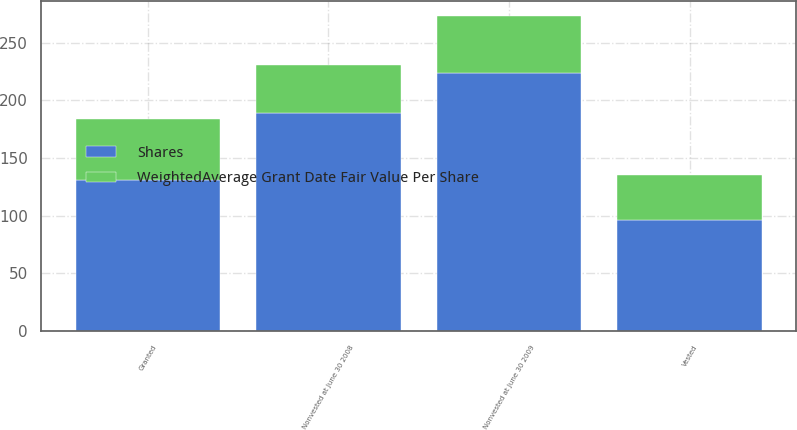Convert chart. <chart><loc_0><loc_0><loc_500><loc_500><stacked_bar_chart><ecel><fcel>Nonvested at June 30 2008<fcel>Granted<fcel>Vested<fcel>Nonvested at June 30 2009<nl><fcel>Shares<fcel>189.3<fcel>131<fcel>96.1<fcel>224.2<nl><fcel>WeightedAverage Grant Date Fair Value Per Share<fcel>41.05<fcel>52.83<fcel>39.56<fcel>48.57<nl></chart> 